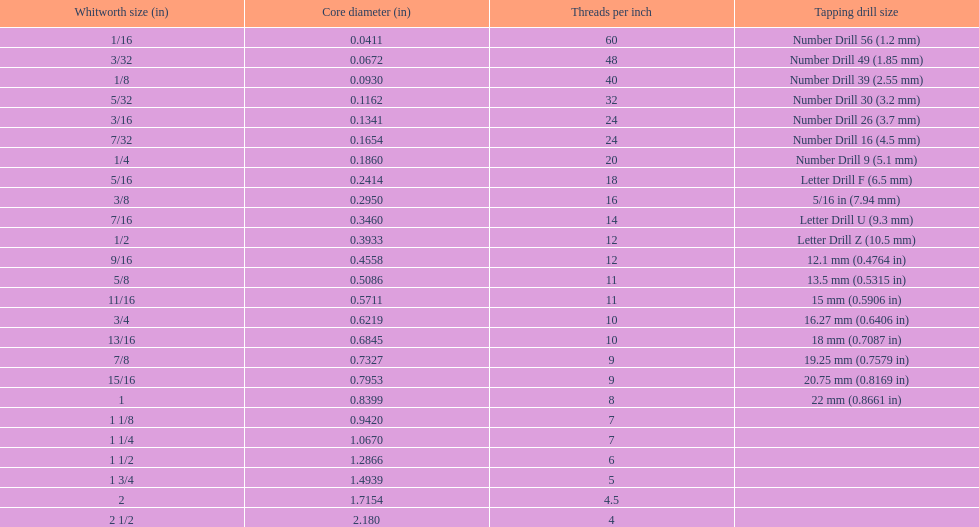Which whitworth size is the only one with 5 threads per inch? 1 3/4. 